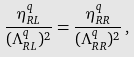Convert formula to latex. <formula><loc_0><loc_0><loc_500><loc_500>\frac { \eta ^ { q } _ { R L } } { ( \Lambda ^ { q } _ { R L } ) ^ { 2 } } = \frac { \eta ^ { q } _ { R R } } { ( \Lambda ^ { q } _ { R R } ) ^ { 2 } } \, ,</formula> 